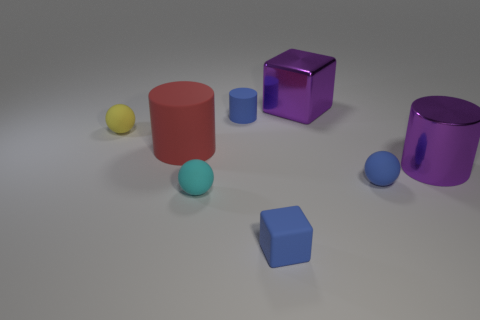There is a small blue cylinder; how many objects are in front of it?
Your response must be concise. 6. The large metal thing that is behind the large purple object that is in front of the tiny rubber sphere left of the small cyan matte sphere is what color?
Offer a terse response. Purple. Do the matte thing that is behind the yellow thing and the block that is in front of the yellow ball have the same color?
Give a very brief answer. Yes. What shape is the small blue matte thing behind the large purple object in front of the tiny yellow matte sphere?
Ensure brevity in your answer.  Cylinder. Are there any brown metallic cubes that have the same size as the blue matte ball?
Provide a short and direct response. No. How many other red objects have the same shape as the red thing?
Offer a terse response. 0. Are there the same number of tiny rubber cylinders that are in front of the small yellow ball and purple metal cylinders that are behind the blue rubber block?
Provide a short and direct response. No. Is there a blue shiny ball?
Provide a short and direct response. No. What size is the cylinder that is to the right of the tiny sphere to the right of the tiny rubber block right of the cyan matte ball?
Give a very brief answer. Large. What shape is the cyan rubber thing that is the same size as the blue matte block?
Offer a terse response. Sphere. 